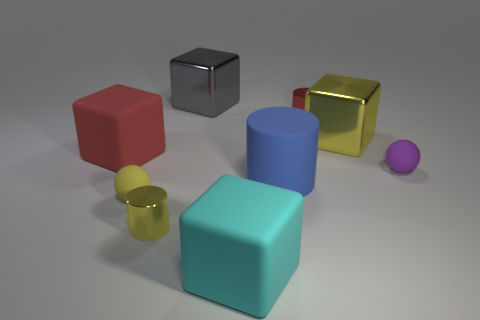Subtract 1 cubes. How many cubes are left? 3 Subtract all spheres. How many objects are left? 7 Subtract 1 red cubes. How many objects are left? 8 Subtract all matte cylinders. Subtract all big red rubber objects. How many objects are left? 7 Add 4 yellow rubber spheres. How many yellow rubber spheres are left? 5 Add 2 large matte blocks. How many large matte blocks exist? 4 